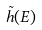<formula> <loc_0><loc_0><loc_500><loc_500>\tilde { h } ( E )</formula> 